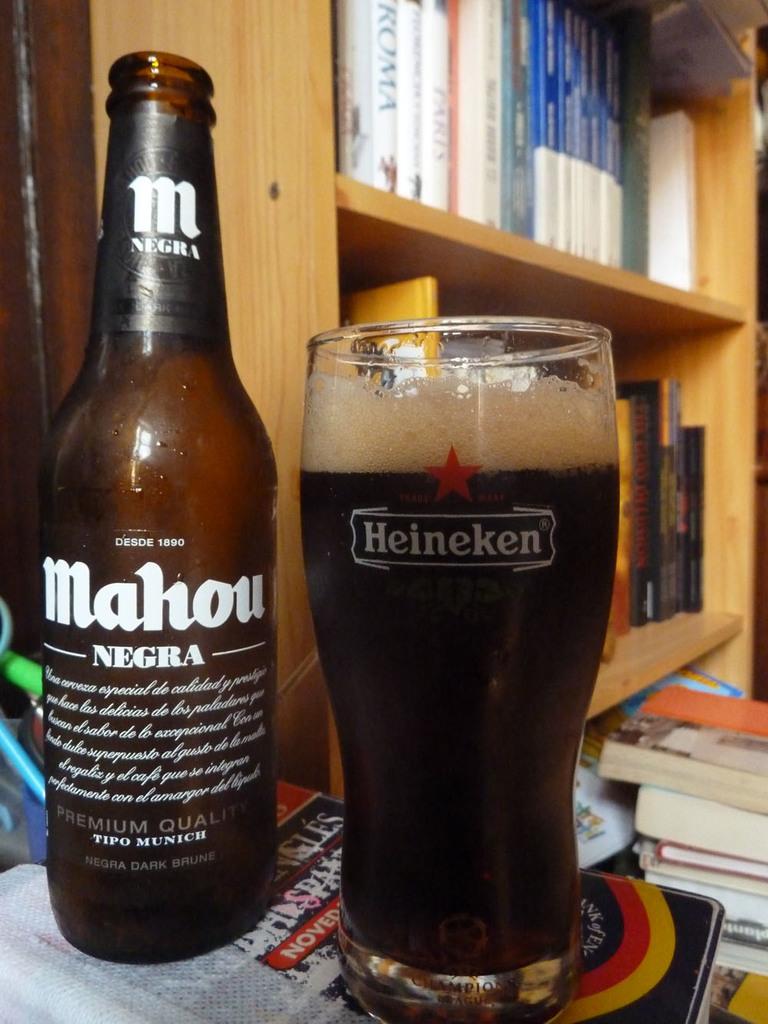What company logo is printed on the glass on the right?
Make the answer very short. Heineken. Wow what a brand it is?
Provide a succinct answer. Heineken. 